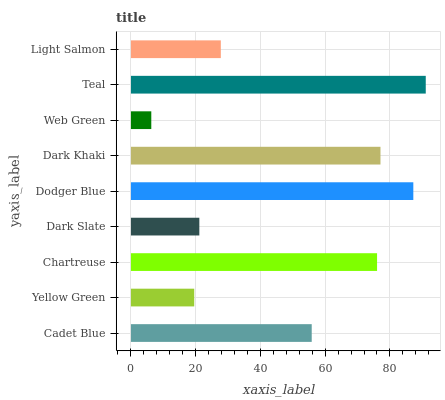Is Web Green the minimum?
Answer yes or no. Yes. Is Teal the maximum?
Answer yes or no. Yes. Is Yellow Green the minimum?
Answer yes or no. No. Is Yellow Green the maximum?
Answer yes or no. No. Is Cadet Blue greater than Yellow Green?
Answer yes or no. Yes. Is Yellow Green less than Cadet Blue?
Answer yes or no. Yes. Is Yellow Green greater than Cadet Blue?
Answer yes or no. No. Is Cadet Blue less than Yellow Green?
Answer yes or no. No. Is Cadet Blue the high median?
Answer yes or no. Yes. Is Cadet Blue the low median?
Answer yes or no. Yes. Is Chartreuse the high median?
Answer yes or no. No. Is Dodger Blue the low median?
Answer yes or no. No. 